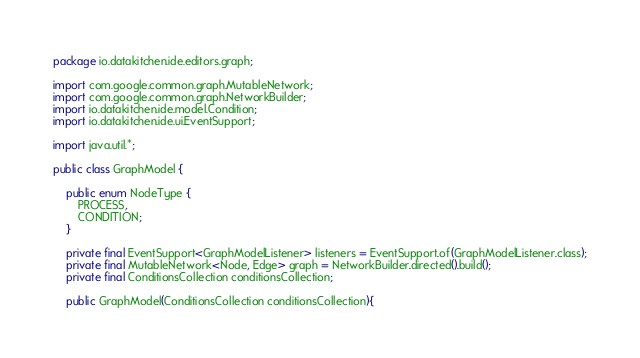Convert code to text. <code><loc_0><loc_0><loc_500><loc_500><_Java_>package io.datakitchen.ide.editors.graph;

import com.google.common.graph.MutableNetwork;
import com.google.common.graph.NetworkBuilder;
import io.datakitchen.ide.model.Condition;
import io.datakitchen.ide.ui.EventSupport;

import java.util.*;

public class GraphModel {

    public enum NodeType {
        PROCESS,
        CONDITION;
    }

    private final EventSupport<GraphModelListener> listeners = EventSupport.of(GraphModelListener.class);
    private final MutableNetwork<Node, Edge> graph = NetworkBuilder.directed().build();
    private final ConditionsCollection conditionsCollection;

    public GraphModel(ConditionsCollection conditionsCollection){</code> 